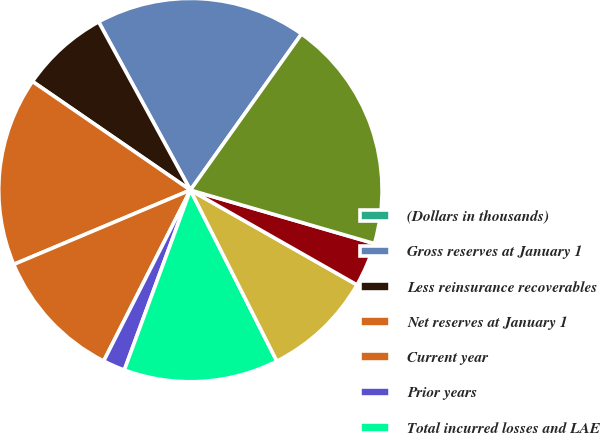Convert chart to OTSL. <chart><loc_0><loc_0><loc_500><loc_500><pie_chart><fcel>(Dollars in thousands)<fcel>Gross reserves at January 1<fcel>Less reinsurance recoverables<fcel>Net reserves at January 1<fcel>Current year<fcel>Prior years<fcel>Total incurred losses and LAE<fcel>Total paid losses and LAE<fcel>Foreign exchange/translation<fcel>Net reserves at December 31<nl><fcel>0.0%<fcel>17.79%<fcel>7.46%<fcel>15.93%<fcel>11.19%<fcel>1.87%<fcel>13.05%<fcel>9.32%<fcel>3.73%<fcel>19.66%<nl></chart> 